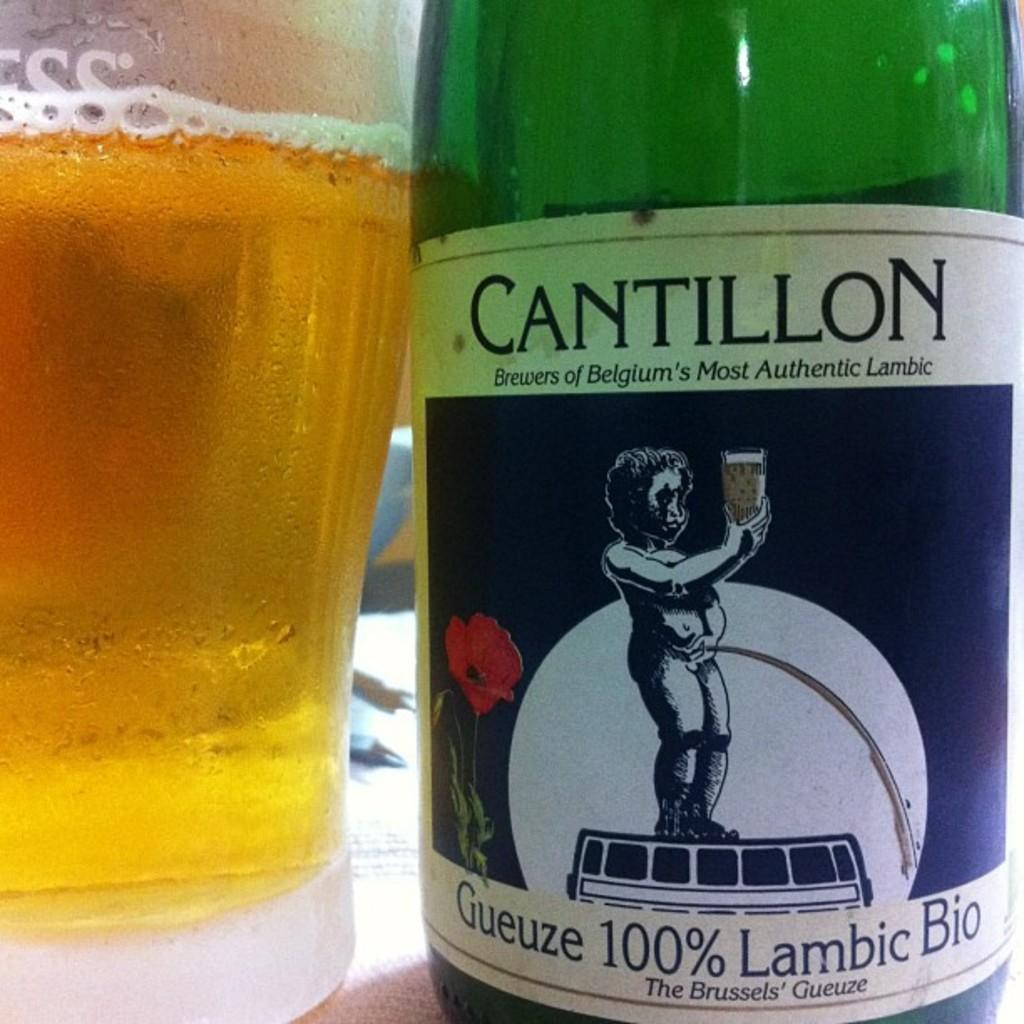<image>
Describe the image concisely. A bottle of Cantillion Lambic sits next to a frothy glass. 